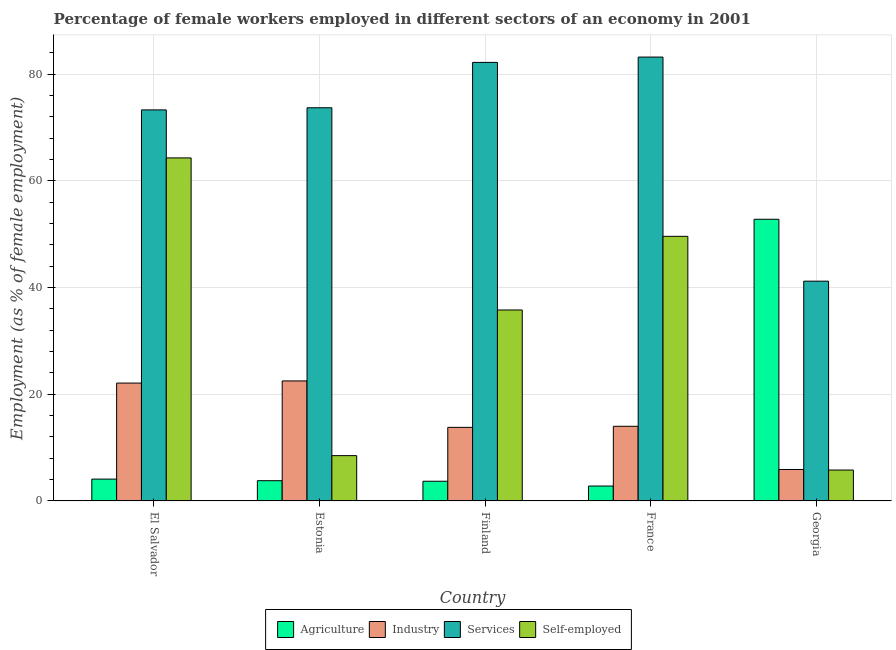How many different coloured bars are there?
Your response must be concise. 4. How many groups of bars are there?
Provide a short and direct response. 5. How many bars are there on the 3rd tick from the left?
Your response must be concise. 4. How many bars are there on the 4th tick from the right?
Your answer should be compact. 4. What is the label of the 2nd group of bars from the left?
Your answer should be compact. Estonia. In how many cases, is the number of bars for a given country not equal to the number of legend labels?
Make the answer very short. 0. What is the percentage of female workers in agriculture in Estonia?
Keep it short and to the point. 3.8. Across all countries, what is the minimum percentage of self employed female workers?
Give a very brief answer. 5.8. In which country was the percentage of female workers in services maximum?
Offer a very short reply. France. In which country was the percentage of female workers in industry minimum?
Make the answer very short. Georgia. What is the total percentage of female workers in services in the graph?
Give a very brief answer. 353.6. What is the difference between the percentage of female workers in services in El Salvador and the percentage of female workers in agriculture in France?
Keep it short and to the point. 70.5. What is the average percentage of female workers in agriculture per country?
Provide a succinct answer. 13.44. What is the difference between the percentage of self employed female workers and percentage of female workers in services in Estonia?
Offer a very short reply. -65.2. What is the ratio of the percentage of female workers in industry in El Salvador to that in France?
Offer a very short reply. 1.58. Is the percentage of female workers in industry in Finland less than that in Georgia?
Ensure brevity in your answer.  No. What is the difference between the highest and the second highest percentage of self employed female workers?
Make the answer very short. 14.7. What is the difference between the highest and the lowest percentage of self employed female workers?
Make the answer very short. 58.5. In how many countries, is the percentage of female workers in industry greater than the average percentage of female workers in industry taken over all countries?
Provide a succinct answer. 2. Is the sum of the percentage of female workers in agriculture in France and Georgia greater than the maximum percentage of self employed female workers across all countries?
Give a very brief answer. No. What does the 1st bar from the left in Georgia represents?
Provide a short and direct response. Agriculture. What does the 4th bar from the right in Estonia represents?
Offer a terse response. Agriculture. Are all the bars in the graph horizontal?
Ensure brevity in your answer.  No. How many countries are there in the graph?
Offer a terse response. 5. What is the difference between two consecutive major ticks on the Y-axis?
Your answer should be very brief. 20. Are the values on the major ticks of Y-axis written in scientific E-notation?
Make the answer very short. No. Where does the legend appear in the graph?
Provide a short and direct response. Bottom center. How many legend labels are there?
Provide a succinct answer. 4. How are the legend labels stacked?
Offer a very short reply. Horizontal. What is the title of the graph?
Keep it short and to the point. Percentage of female workers employed in different sectors of an economy in 2001. Does "Payroll services" appear as one of the legend labels in the graph?
Ensure brevity in your answer.  No. What is the label or title of the X-axis?
Ensure brevity in your answer.  Country. What is the label or title of the Y-axis?
Your answer should be very brief. Employment (as % of female employment). What is the Employment (as % of female employment) of Agriculture in El Salvador?
Offer a terse response. 4.1. What is the Employment (as % of female employment) in Industry in El Salvador?
Keep it short and to the point. 22.1. What is the Employment (as % of female employment) of Services in El Salvador?
Your answer should be very brief. 73.3. What is the Employment (as % of female employment) in Self-employed in El Salvador?
Your response must be concise. 64.3. What is the Employment (as % of female employment) of Agriculture in Estonia?
Your answer should be very brief. 3.8. What is the Employment (as % of female employment) in Services in Estonia?
Offer a very short reply. 73.7. What is the Employment (as % of female employment) in Agriculture in Finland?
Ensure brevity in your answer.  3.7. What is the Employment (as % of female employment) of Industry in Finland?
Your answer should be very brief. 13.8. What is the Employment (as % of female employment) in Services in Finland?
Your response must be concise. 82.2. What is the Employment (as % of female employment) of Self-employed in Finland?
Your response must be concise. 35.8. What is the Employment (as % of female employment) of Agriculture in France?
Offer a very short reply. 2.8. What is the Employment (as % of female employment) in Services in France?
Your answer should be very brief. 83.2. What is the Employment (as % of female employment) of Self-employed in France?
Keep it short and to the point. 49.6. What is the Employment (as % of female employment) of Agriculture in Georgia?
Offer a very short reply. 52.8. What is the Employment (as % of female employment) of Industry in Georgia?
Provide a short and direct response. 5.9. What is the Employment (as % of female employment) of Services in Georgia?
Offer a very short reply. 41.2. What is the Employment (as % of female employment) of Self-employed in Georgia?
Make the answer very short. 5.8. Across all countries, what is the maximum Employment (as % of female employment) of Agriculture?
Offer a very short reply. 52.8. Across all countries, what is the maximum Employment (as % of female employment) of Industry?
Ensure brevity in your answer.  22.5. Across all countries, what is the maximum Employment (as % of female employment) in Services?
Ensure brevity in your answer.  83.2. Across all countries, what is the maximum Employment (as % of female employment) in Self-employed?
Your response must be concise. 64.3. Across all countries, what is the minimum Employment (as % of female employment) of Agriculture?
Give a very brief answer. 2.8. Across all countries, what is the minimum Employment (as % of female employment) in Industry?
Your answer should be very brief. 5.9. Across all countries, what is the minimum Employment (as % of female employment) in Services?
Make the answer very short. 41.2. Across all countries, what is the minimum Employment (as % of female employment) of Self-employed?
Your answer should be compact. 5.8. What is the total Employment (as % of female employment) in Agriculture in the graph?
Your answer should be very brief. 67.2. What is the total Employment (as % of female employment) in Industry in the graph?
Your answer should be compact. 78.3. What is the total Employment (as % of female employment) in Services in the graph?
Your response must be concise. 353.6. What is the total Employment (as % of female employment) of Self-employed in the graph?
Your response must be concise. 164. What is the difference between the Employment (as % of female employment) of Industry in El Salvador and that in Estonia?
Offer a terse response. -0.4. What is the difference between the Employment (as % of female employment) of Services in El Salvador and that in Estonia?
Provide a short and direct response. -0.4. What is the difference between the Employment (as % of female employment) of Self-employed in El Salvador and that in Estonia?
Keep it short and to the point. 55.8. What is the difference between the Employment (as % of female employment) in Services in El Salvador and that in Finland?
Your answer should be compact. -8.9. What is the difference between the Employment (as % of female employment) of Self-employed in El Salvador and that in Finland?
Keep it short and to the point. 28.5. What is the difference between the Employment (as % of female employment) in Industry in El Salvador and that in France?
Make the answer very short. 8.1. What is the difference between the Employment (as % of female employment) in Services in El Salvador and that in France?
Offer a terse response. -9.9. What is the difference between the Employment (as % of female employment) of Self-employed in El Salvador and that in France?
Ensure brevity in your answer.  14.7. What is the difference between the Employment (as % of female employment) of Agriculture in El Salvador and that in Georgia?
Your answer should be compact. -48.7. What is the difference between the Employment (as % of female employment) in Services in El Salvador and that in Georgia?
Offer a terse response. 32.1. What is the difference between the Employment (as % of female employment) in Self-employed in El Salvador and that in Georgia?
Offer a very short reply. 58.5. What is the difference between the Employment (as % of female employment) in Agriculture in Estonia and that in Finland?
Give a very brief answer. 0.1. What is the difference between the Employment (as % of female employment) of Services in Estonia and that in Finland?
Make the answer very short. -8.5. What is the difference between the Employment (as % of female employment) in Self-employed in Estonia and that in Finland?
Offer a very short reply. -27.3. What is the difference between the Employment (as % of female employment) in Services in Estonia and that in France?
Ensure brevity in your answer.  -9.5. What is the difference between the Employment (as % of female employment) of Self-employed in Estonia and that in France?
Keep it short and to the point. -41.1. What is the difference between the Employment (as % of female employment) in Agriculture in Estonia and that in Georgia?
Make the answer very short. -49. What is the difference between the Employment (as % of female employment) in Services in Estonia and that in Georgia?
Provide a succinct answer. 32.5. What is the difference between the Employment (as % of female employment) of Industry in Finland and that in France?
Offer a very short reply. -0.2. What is the difference between the Employment (as % of female employment) in Agriculture in Finland and that in Georgia?
Make the answer very short. -49.1. What is the difference between the Employment (as % of female employment) of Self-employed in Finland and that in Georgia?
Ensure brevity in your answer.  30. What is the difference between the Employment (as % of female employment) in Agriculture in France and that in Georgia?
Ensure brevity in your answer.  -50. What is the difference between the Employment (as % of female employment) of Industry in France and that in Georgia?
Ensure brevity in your answer.  8.1. What is the difference between the Employment (as % of female employment) in Services in France and that in Georgia?
Ensure brevity in your answer.  42. What is the difference between the Employment (as % of female employment) of Self-employed in France and that in Georgia?
Keep it short and to the point. 43.8. What is the difference between the Employment (as % of female employment) in Agriculture in El Salvador and the Employment (as % of female employment) in Industry in Estonia?
Ensure brevity in your answer.  -18.4. What is the difference between the Employment (as % of female employment) in Agriculture in El Salvador and the Employment (as % of female employment) in Services in Estonia?
Your answer should be compact. -69.6. What is the difference between the Employment (as % of female employment) of Agriculture in El Salvador and the Employment (as % of female employment) of Self-employed in Estonia?
Give a very brief answer. -4.4. What is the difference between the Employment (as % of female employment) in Industry in El Salvador and the Employment (as % of female employment) in Services in Estonia?
Offer a terse response. -51.6. What is the difference between the Employment (as % of female employment) in Industry in El Salvador and the Employment (as % of female employment) in Self-employed in Estonia?
Provide a short and direct response. 13.6. What is the difference between the Employment (as % of female employment) of Services in El Salvador and the Employment (as % of female employment) of Self-employed in Estonia?
Keep it short and to the point. 64.8. What is the difference between the Employment (as % of female employment) in Agriculture in El Salvador and the Employment (as % of female employment) in Services in Finland?
Make the answer very short. -78.1. What is the difference between the Employment (as % of female employment) in Agriculture in El Salvador and the Employment (as % of female employment) in Self-employed in Finland?
Your answer should be compact. -31.7. What is the difference between the Employment (as % of female employment) in Industry in El Salvador and the Employment (as % of female employment) in Services in Finland?
Your response must be concise. -60.1. What is the difference between the Employment (as % of female employment) of Industry in El Salvador and the Employment (as % of female employment) of Self-employed in Finland?
Your response must be concise. -13.7. What is the difference between the Employment (as % of female employment) of Services in El Salvador and the Employment (as % of female employment) of Self-employed in Finland?
Provide a succinct answer. 37.5. What is the difference between the Employment (as % of female employment) of Agriculture in El Salvador and the Employment (as % of female employment) of Industry in France?
Your response must be concise. -9.9. What is the difference between the Employment (as % of female employment) in Agriculture in El Salvador and the Employment (as % of female employment) in Services in France?
Your answer should be very brief. -79.1. What is the difference between the Employment (as % of female employment) of Agriculture in El Salvador and the Employment (as % of female employment) of Self-employed in France?
Ensure brevity in your answer.  -45.5. What is the difference between the Employment (as % of female employment) of Industry in El Salvador and the Employment (as % of female employment) of Services in France?
Your response must be concise. -61.1. What is the difference between the Employment (as % of female employment) of Industry in El Salvador and the Employment (as % of female employment) of Self-employed in France?
Make the answer very short. -27.5. What is the difference between the Employment (as % of female employment) in Services in El Salvador and the Employment (as % of female employment) in Self-employed in France?
Offer a very short reply. 23.7. What is the difference between the Employment (as % of female employment) in Agriculture in El Salvador and the Employment (as % of female employment) in Industry in Georgia?
Provide a succinct answer. -1.8. What is the difference between the Employment (as % of female employment) in Agriculture in El Salvador and the Employment (as % of female employment) in Services in Georgia?
Keep it short and to the point. -37.1. What is the difference between the Employment (as % of female employment) of Agriculture in El Salvador and the Employment (as % of female employment) of Self-employed in Georgia?
Give a very brief answer. -1.7. What is the difference between the Employment (as % of female employment) in Industry in El Salvador and the Employment (as % of female employment) in Services in Georgia?
Your answer should be compact. -19.1. What is the difference between the Employment (as % of female employment) of Industry in El Salvador and the Employment (as % of female employment) of Self-employed in Georgia?
Your answer should be very brief. 16.3. What is the difference between the Employment (as % of female employment) of Services in El Salvador and the Employment (as % of female employment) of Self-employed in Georgia?
Provide a succinct answer. 67.5. What is the difference between the Employment (as % of female employment) of Agriculture in Estonia and the Employment (as % of female employment) of Services in Finland?
Offer a terse response. -78.4. What is the difference between the Employment (as % of female employment) in Agriculture in Estonia and the Employment (as % of female employment) in Self-employed in Finland?
Offer a very short reply. -32. What is the difference between the Employment (as % of female employment) of Industry in Estonia and the Employment (as % of female employment) of Services in Finland?
Provide a short and direct response. -59.7. What is the difference between the Employment (as % of female employment) in Industry in Estonia and the Employment (as % of female employment) in Self-employed in Finland?
Keep it short and to the point. -13.3. What is the difference between the Employment (as % of female employment) in Services in Estonia and the Employment (as % of female employment) in Self-employed in Finland?
Provide a short and direct response. 37.9. What is the difference between the Employment (as % of female employment) of Agriculture in Estonia and the Employment (as % of female employment) of Industry in France?
Your answer should be very brief. -10.2. What is the difference between the Employment (as % of female employment) of Agriculture in Estonia and the Employment (as % of female employment) of Services in France?
Offer a terse response. -79.4. What is the difference between the Employment (as % of female employment) of Agriculture in Estonia and the Employment (as % of female employment) of Self-employed in France?
Your response must be concise. -45.8. What is the difference between the Employment (as % of female employment) of Industry in Estonia and the Employment (as % of female employment) of Services in France?
Give a very brief answer. -60.7. What is the difference between the Employment (as % of female employment) in Industry in Estonia and the Employment (as % of female employment) in Self-employed in France?
Give a very brief answer. -27.1. What is the difference between the Employment (as % of female employment) in Services in Estonia and the Employment (as % of female employment) in Self-employed in France?
Your answer should be very brief. 24.1. What is the difference between the Employment (as % of female employment) of Agriculture in Estonia and the Employment (as % of female employment) of Services in Georgia?
Provide a short and direct response. -37.4. What is the difference between the Employment (as % of female employment) in Industry in Estonia and the Employment (as % of female employment) in Services in Georgia?
Your answer should be very brief. -18.7. What is the difference between the Employment (as % of female employment) of Services in Estonia and the Employment (as % of female employment) of Self-employed in Georgia?
Provide a short and direct response. 67.9. What is the difference between the Employment (as % of female employment) in Agriculture in Finland and the Employment (as % of female employment) in Industry in France?
Make the answer very short. -10.3. What is the difference between the Employment (as % of female employment) in Agriculture in Finland and the Employment (as % of female employment) in Services in France?
Your answer should be very brief. -79.5. What is the difference between the Employment (as % of female employment) of Agriculture in Finland and the Employment (as % of female employment) of Self-employed in France?
Keep it short and to the point. -45.9. What is the difference between the Employment (as % of female employment) in Industry in Finland and the Employment (as % of female employment) in Services in France?
Offer a terse response. -69.4. What is the difference between the Employment (as % of female employment) of Industry in Finland and the Employment (as % of female employment) of Self-employed in France?
Your answer should be very brief. -35.8. What is the difference between the Employment (as % of female employment) of Services in Finland and the Employment (as % of female employment) of Self-employed in France?
Offer a very short reply. 32.6. What is the difference between the Employment (as % of female employment) of Agriculture in Finland and the Employment (as % of female employment) of Industry in Georgia?
Offer a terse response. -2.2. What is the difference between the Employment (as % of female employment) of Agriculture in Finland and the Employment (as % of female employment) of Services in Georgia?
Offer a terse response. -37.5. What is the difference between the Employment (as % of female employment) in Agriculture in Finland and the Employment (as % of female employment) in Self-employed in Georgia?
Offer a terse response. -2.1. What is the difference between the Employment (as % of female employment) of Industry in Finland and the Employment (as % of female employment) of Services in Georgia?
Make the answer very short. -27.4. What is the difference between the Employment (as % of female employment) of Services in Finland and the Employment (as % of female employment) of Self-employed in Georgia?
Your answer should be very brief. 76.4. What is the difference between the Employment (as % of female employment) of Agriculture in France and the Employment (as % of female employment) of Services in Georgia?
Provide a succinct answer. -38.4. What is the difference between the Employment (as % of female employment) in Industry in France and the Employment (as % of female employment) in Services in Georgia?
Make the answer very short. -27.2. What is the difference between the Employment (as % of female employment) in Services in France and the Employment (as % of female employment) in Self-employed in Georgia?
Ensure brevity in your answer.  77.4. What is the average Employment (as % of female employment) of Agriculture per country?
Ensure brevity in your answer.  13.44. What is the average Employment (as % of female employment) in Industry per country?
Make the answer very short. 15.66. What is the average Employment (as % of female employment) in Services per country?
Offer a very short reply. 70.72. What is the average Employment (as % of female employment) of Self-employed per country?
Provide a short and direct response. 32.8. What is the difference between the Employment (as % of female employment) in Agriculture and Employment (as % of female employment) in Industry in El Salvador?
Ensure brevity in your answer.  -18. What is the difference between the Employment (as % of female employment) of Agriculture and Employment (as % of female employment) of Services in El Salvador?
Provide a short and direct response. -69.2. What is the difference between the Employment (as % of female employment) in Agriculture and Employment (as % of female employment) in Self-employed in El Salvador?
Your answer should be compact. -60.2. What is the difference between the Employment (as % of female employment) of Industry and Employment (as % of female employment) of Services in El Salvador?
Your answer should be compact. -51.2. What is the difference between the Employment (as % of female employment) of Industry and Employment (as % of female employment) of Self-employed in El Salvador?
Your answer should be very brief. -42.2. What is the difference between the Employment (as % of female employment) in Agriculture and Employment (as % of female employment) in Industry in Estonia?
Give a very brief answer. -18.7. What is the difference between the Employment (as % of female employment) in Agriculture and Employment (as % of female employment) in Services in Estonia?
Provide a succinct answer. -69.9. What is the difference between the Employment (as % of female employment) in Agriculture and Employment (as % of female employment) in Self-employed in Estonia?
Make the answer very short. -4.7. What is the difference between the Employment (as % of female employment) in Industry and Employment (as % of female employment) in Services in Estonia?
Keep it short and to the point. -51.2. What is the difference between the Employment (as % of female employment) of Services and Employment (as % of female employment) of Self-employed in Estonia?
Your answer should be compact. 65.2. What is the difference between the Employment (as % of female employment) of Agriculture and Employment (as % of female employment) of Industry in Finland?
Offer a terse response. -10.1. What is the difference between the Employment (as % of female employment) of Agriculture and Employment (as % of female employment) of Services in Finland?
Provide a succinct answer. -78.5. What is the difference between the Employment (as % of female employment) of Agriculture and Employment (as % of female employment) of Self-employed in Finland?
Your answer should be very brief. -32.1. What is the difference between the Employment (as % of female employment) in Industry and Employment (as % of female employment) in Services in Finland?
Provide a succinct answer. -68.4. What is the difference between the Employment (as % of female employment) in Services and Employment (as % of female employment) in Self-employed in Finland?
Keep it short and to the point. 46.4. What is the difference between the Employment (as % of female employment) in Agriculture and Employment (as % of female employment) in Industry in France?
Your response must be concise. -11.2. What is the difference between the Employment (as % of female employment) of Agriculture and Employment (as % of female employment) of Services in France?
Ensure brevity in your answer.  -80.4. What is the difference between the Employment (as % of female employment) in Agriculture and Employment (as % of female employment) in Self-employed in France?
Provide a succinct answer. -46.8. What is the difference between the Employment (as % of female employment) in Industry and Employment (as % of female employment) in Services in France?
Your answer should be compact. -69.2. What is the difference between the Employment (as % of female employment) in Industry and Employment (as % of female employment) in Self-employed in France?
Keep it short and to the point. -35.6. What is the difference between the Employment (as % of female employment) in Services and Employment (as % of female employment) in Self-employed in France?
Offer a terse response. 33.6. What is the difference between the Employment (as % of female employment) in Agriculture and Employment (as % of female employment) in Industry in Georgia?
Make the answer very short. 46.9. What is the difference between the Employment (as % of female employment) of Agriculture and Employment (as % of female employment) of Services in Georgia?
Offer a terse response. 11.6. What is the difference between the Employment (as % of female employment) in Industry and Employment (as % of female employment) in Services in Georgia?
Make the answer very short. -35.3. What is the difference between the Employment (as % of female employment) of Services and Employment (as % of female employment) of Self-employed in Georgia?
Your answer should be compact. 35.4. What is the ratio of the Employment (as % of female employment) in Agriculture in El Salvador to that in Estonia?
Provide a succinct answer. 1.08. What is the ratio of the Employment (as % of female employment) in Industry in El Salvador to that in Estonia?
Provide a succinct answer. 0.98. What is the ratio of the Employment (as % of female employment) in Services in El Salvador to that in Estonia?
Make the answer very short. 0.99. What is the ratio of the Employment (as % of female employment) of Self-employed in El Salvador to that in Estonia?
Make the answer very short. 7.56. What is the ratio of the Employment (as % of female employment) of Agriculture in El Salvador to that in Finland?
Your answer should be very brief. 1.11. What is the ratio of the Employment (as % of female employment) of Industry in El Salvador to that in Finland?
Your answer should be compact. 1.6. What is the ratio of the Employment (as % of female employment) of Services in El Salvador to that in Finland?
Offer a very short reply. 0.89. What is the ratio of the Employment (as % of female employment) in Self-employed in El Salvador to that in Finland?
Provide a short and direct response. 1.8. What is the ratio of the Employment (as % of female employment) in Agriculture in El Salvador to that in France?
Your answer should be very brief. 1.46. What is the ratio of the Employment (as % of female employment) in Industry in El Salvador to that in France?
Offer a terse response. 1.58. What is the ratio of the Employment (as % of female employment) in Services in El Salvador to that in France?
Your response must be concise. 0.88. What is the ratio of the Employment (as % of female employment) of Self-employed in El Salvador to that in France?
Your response must be concise. 1.3. What is the ratio of the Employment (as % of female employment) of Agriculture in El Salvador to that in Georgia?
Ensure brevity in your answer.  0.08. What is the ratio of the Employment (as % of female employment) in Industry in El Salvador to that in Georgia?
Provide a short and direct response. 3.75. What is the ratio of the Employment (as % of female employment) in Services in El Salvador to that in Georgia?
Keep it short and to the point. 1.78. What is the ratio of the Employment (as % of female employment) of Self-employed in El Salvador to that in Georgia?
Your response must be concise. 11.09. What is the ratio of the Employment (as % of female employment) of Agriculture in Estonia to that in Finland?
Offer a very short reply. 1.03. What is the ratio of the Employment (as % of female employment) of Industry in Estonia to that in Finland?
Keep it short and to the point. 1.63. What is the ratio of the Employment (as % of female employment) of Services in Estonia to that in Finland?
Offer a terse response. 0.9. What is the ratio of the Employment (as % of female employment) in Self-employed in Estonia to that in Finland?
Provide a succinct answer. 0.24. What is the ratio of the Employment (as % of female employment) of Agriculture in Estonia to that in France?
Offer a very short reply. 1.36. What is the ratio of the Employment (as % of female employment) in Industry in Estonia to that in France?
Provide a succinct answer. 1.61. What is the ratio of the Employment (as % of female employment) in Services in Estonia to that in France?
Offer a very short reply. 0.89. What is the ratio of the Employment (as % of female employment) of Self-employed in Estonia to that in France?
Provide a short and direct response. 0.17. What is the ratio of the Employment (as % of female employment) of Agriculture in Estonia to that in Georgia?
Provide a short and direct response. 0.07. What is the ratio of the Employment (as % of female employment) of Industry in Estonia to that in Georgia?
Offer a very short reply. 3.81. What is the ratio of the Employment (as % of female employment) of Services in Estonia to that in Georgia?
Ensure brevity in your answer.  1.79. What is the ratio of the Employment (as % of female employment) of Self-employed in Estonia to that in Georgia?
Make the answer very short. 1.47. What is the ratio of the Employment (as % of female employment) of Agriculture in Finland to that in France?
Ensure brevity in your answer.  1.32. What is the ratio of the Employment (as % of female employment) of Industry in Finland to that in France?
Offer a terse response. 0.99. What is the ratio of the Employment (as % of female employment) of Services in Finland to that in France?
Keep it short and to the point. 0.99. What is the ratio of the Employment (as % of female employment) of Self-employed in Finland to that in France?
Provide a succinct answer. 0.72. What is the ratio of the Employment (as % of female employment) of Agriculture in Finland to that in Georgia?
Keep it short and to the point. 0.07. What is the ratio of the Employment (as % of female employment) in Industry in Finland to that in Georgia?
Your response must be concise. 2.34. What is the ratio of the Employment (as % of female employment) in Services in Finland to that in Georgia?
Provide a short and direct response. 2. What is the ratio of the Employment (as % of female employment) of Self-employed in Finland to that in Georgia?
Offer a terse response. 6.17. What is the ratio of the Employment (as % of female employment) in Agriculture in France to that in Georgia?
Give a very brief answer. 0.05. What is the ratio of the Employment (as % of female employment) in Industry in France to that in Georgia?
Your answer should be very brief. 2.37. What is the ratio of the Employment (as % of female employment) in Services in France to that in Georgia?
Ensure brevity in your answer.  2.02. What is the ratio of the Employment (as % of female employment) in Self-employed in France to that in Georgia?
Provide a short and direct response. 8.55. What is the difference between the highest and the second highest Employment (as % of female employment) in Agriculture?
Keep it short and to the point. 48.7. What is the difference between the highest and the second highest Employment (as % of female employment) of Industry?
Provide a succinct answer. 0.4. What is the difference between the highest and the second highest Employment (as % of female employment) in Services?
Keep it short and to the point. 1. What is the difference between the highest and the lowest Employment (as % of female employment) of Self-employed?
Ensure brevity in your answer.  58.5. 